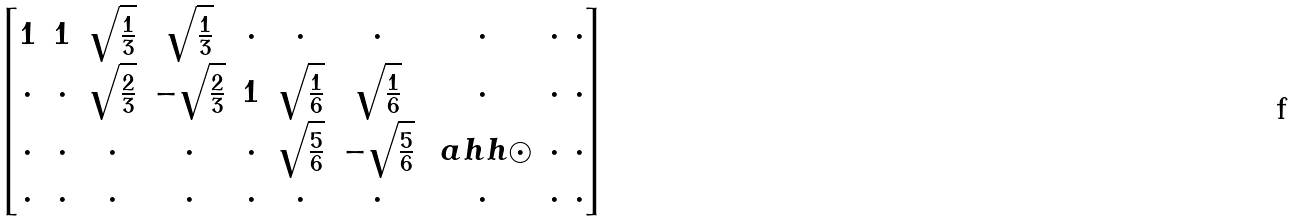<formula> <loc_0><loc_0><loc_500><loc_500>\begin{bmatrix} 1 & 1 & \sqrt { \frac { 1 } { 3 } } & \sqrt { \frac { 1 } { 3 } } & \cdot & \cdot & \cdot & \cdot & \cdot & \cdot \\ \cdot & \cdot & \sqrt { \frac { 2 } { 3 } } & - \sqrt { \frac { 2 } { 3 } } & 1 & \sqrt { \frac { 1 } { 6 } } & \sqrt { \frac { 1 } { 6 } } & \cdot & \cdot & \cdot \\ \cdot & \cdot & \cdot & \cdot & \cdot & \sqrt { \frac { 5 } { 6 } } & - \sqrt { \frac { 5 } { 6 } } & \ a h h { \odot } & \cdot & \cdot \\ \cdot & \cdot & \cdot & \cdot & \cdot & \cdot & \cdot & \cdot & \cdot & \cdot \end{bmatrix}</formula> 